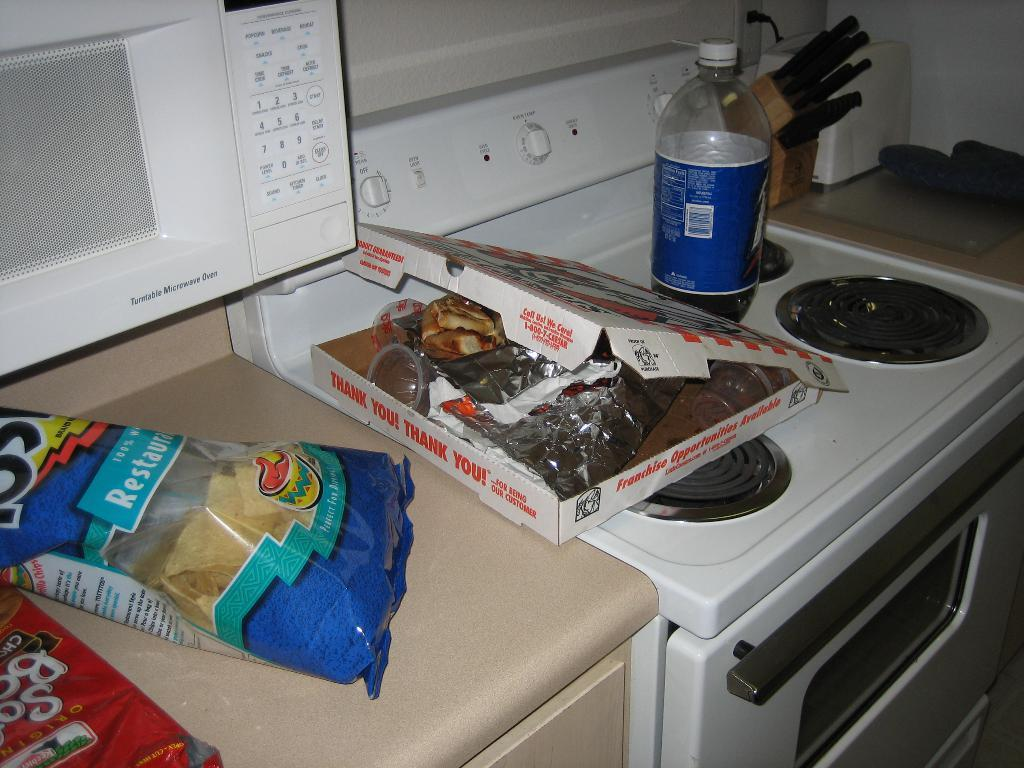<image>
Write a terse but informative summary of the picture. a pizza box and a bag of chips with  thank you written on the box 